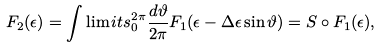<formula> <loc_0><loc_0><loc_500><loc_500>F _ { 2 } ( \epsilon ) = \int \lim i t s _ { 0 } ^ { 2 \pi } \frac { d \vartheta } { 2 \pi } F _ { 1 } ( \epsilon - \Delta \epsilon \sin \vartheta ) = S \circ F _ { 1 } ( \epsilon ) ,</formula> 